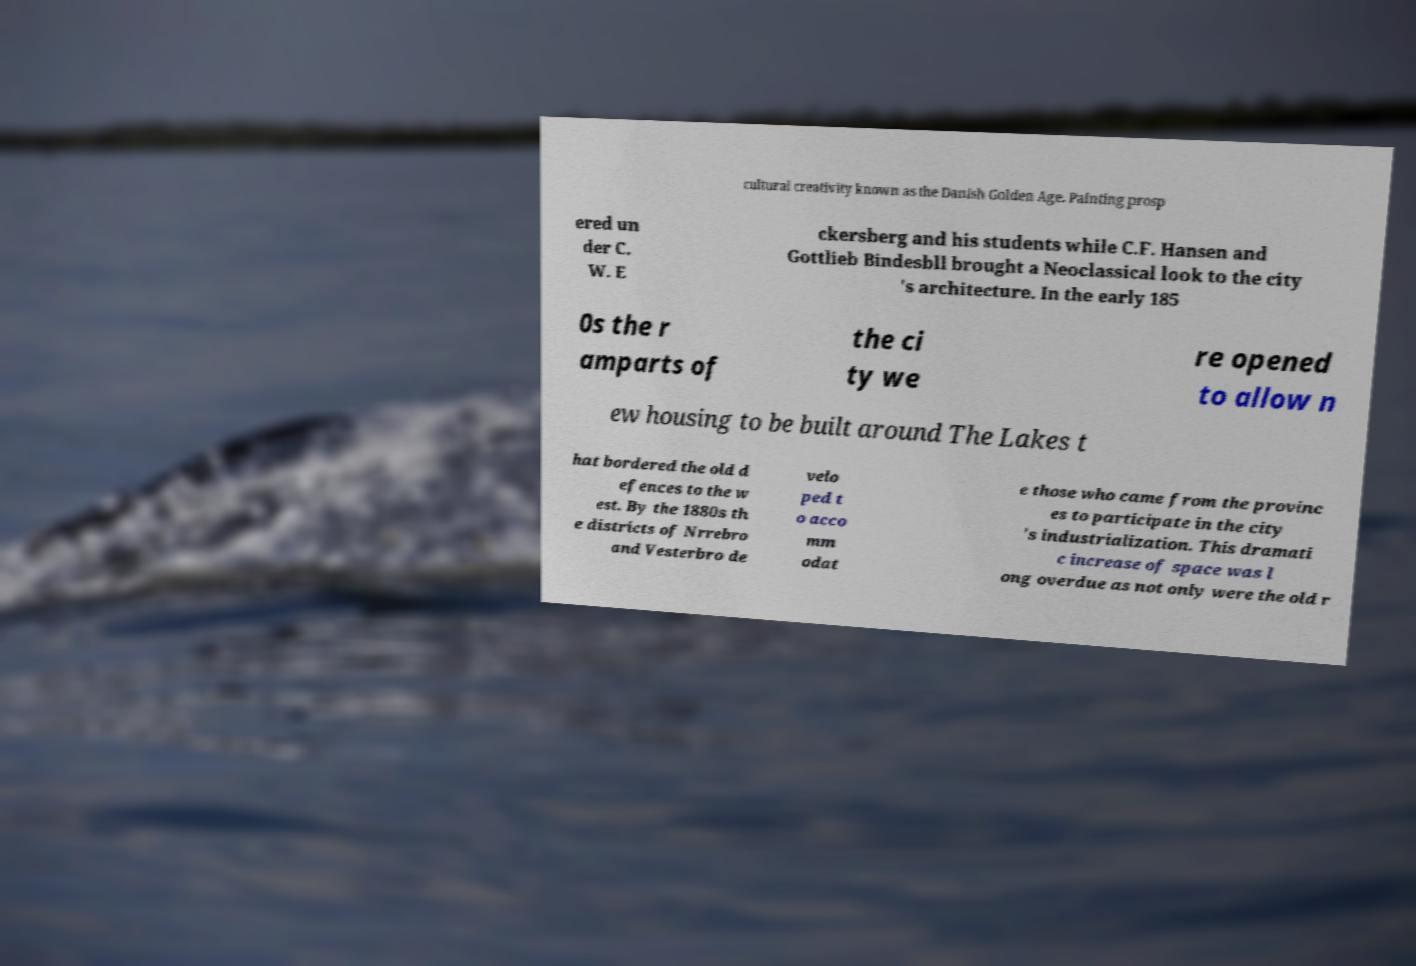Can you read and provide the text displayed in the image?This photo seems to have some interesting text. Can you extract and type it out for me? cultural creativity known as the Danish Golden Age. Painting prosp ered un der C. W. E ckersberg and his students while C.F. Hansen and Gottlieb Bindesbll brought a Neoclassical look to the city 's architecture. In the early 185 0s the r amparts of the ci ty we re opened to allow n ew housing to be built around The Lakes t hat bordered the old d efences to the w est. By the 1880s th e districts of Nrrebro and Vesterbro de velo ped t o acco mm odat e those who came from the provinc es to participate in the city 's industrialization. This dramati c increase of space was l ong overdue as not only were the old r 